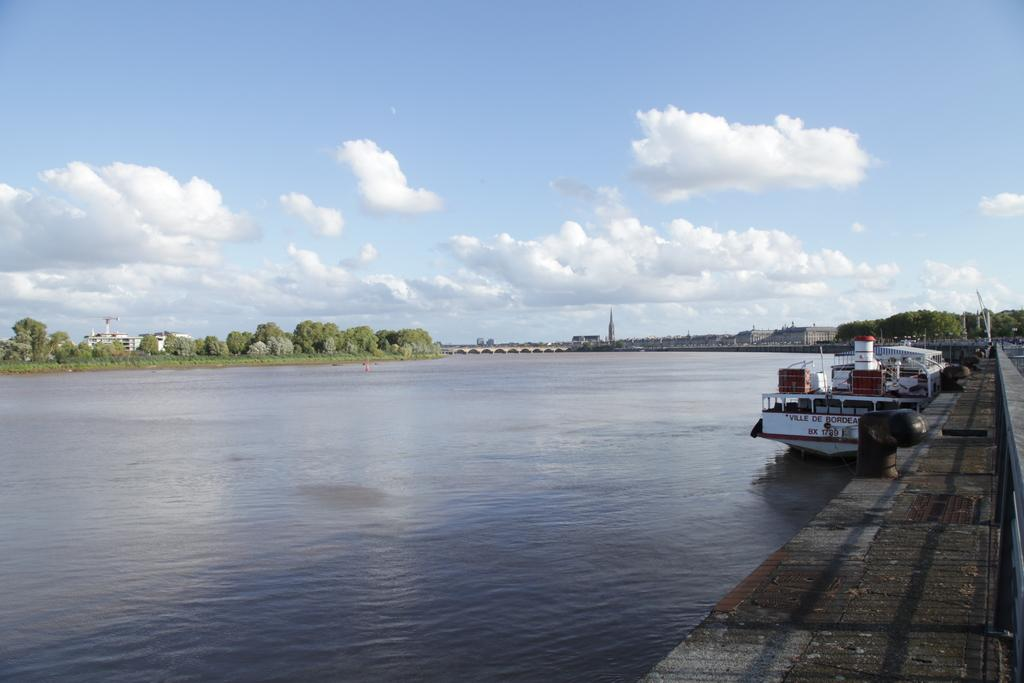What can be seen on the platform in the image? There are pipes on a platform in the image. What is the boat's position in relation to the water? The boat is above the water in the image. What type of natural environment is visible in the background of the image? Trees are visible in the background of the image. What type of man-made structures can be seen in the background of the image? There is a bridge and buildings in the background of the image. What is visible in the sky in the background of the image? The sky is visible in the background of the image, with clouds present. What type of leather is being used to make the chairs in the image? There are no chairs present in the image; it features pipes on a platform, a boat above the water, trees, a bridge, buildings, and a sky with clouds. How many chairs can be seen in the image? There are no chairs present in the image. 